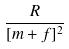Convert formula to latex. <formula><loc_0><loc_0><loc_500><loc_500>\frac { R } { [ m + f ] ^ { 2 } }</formula> 